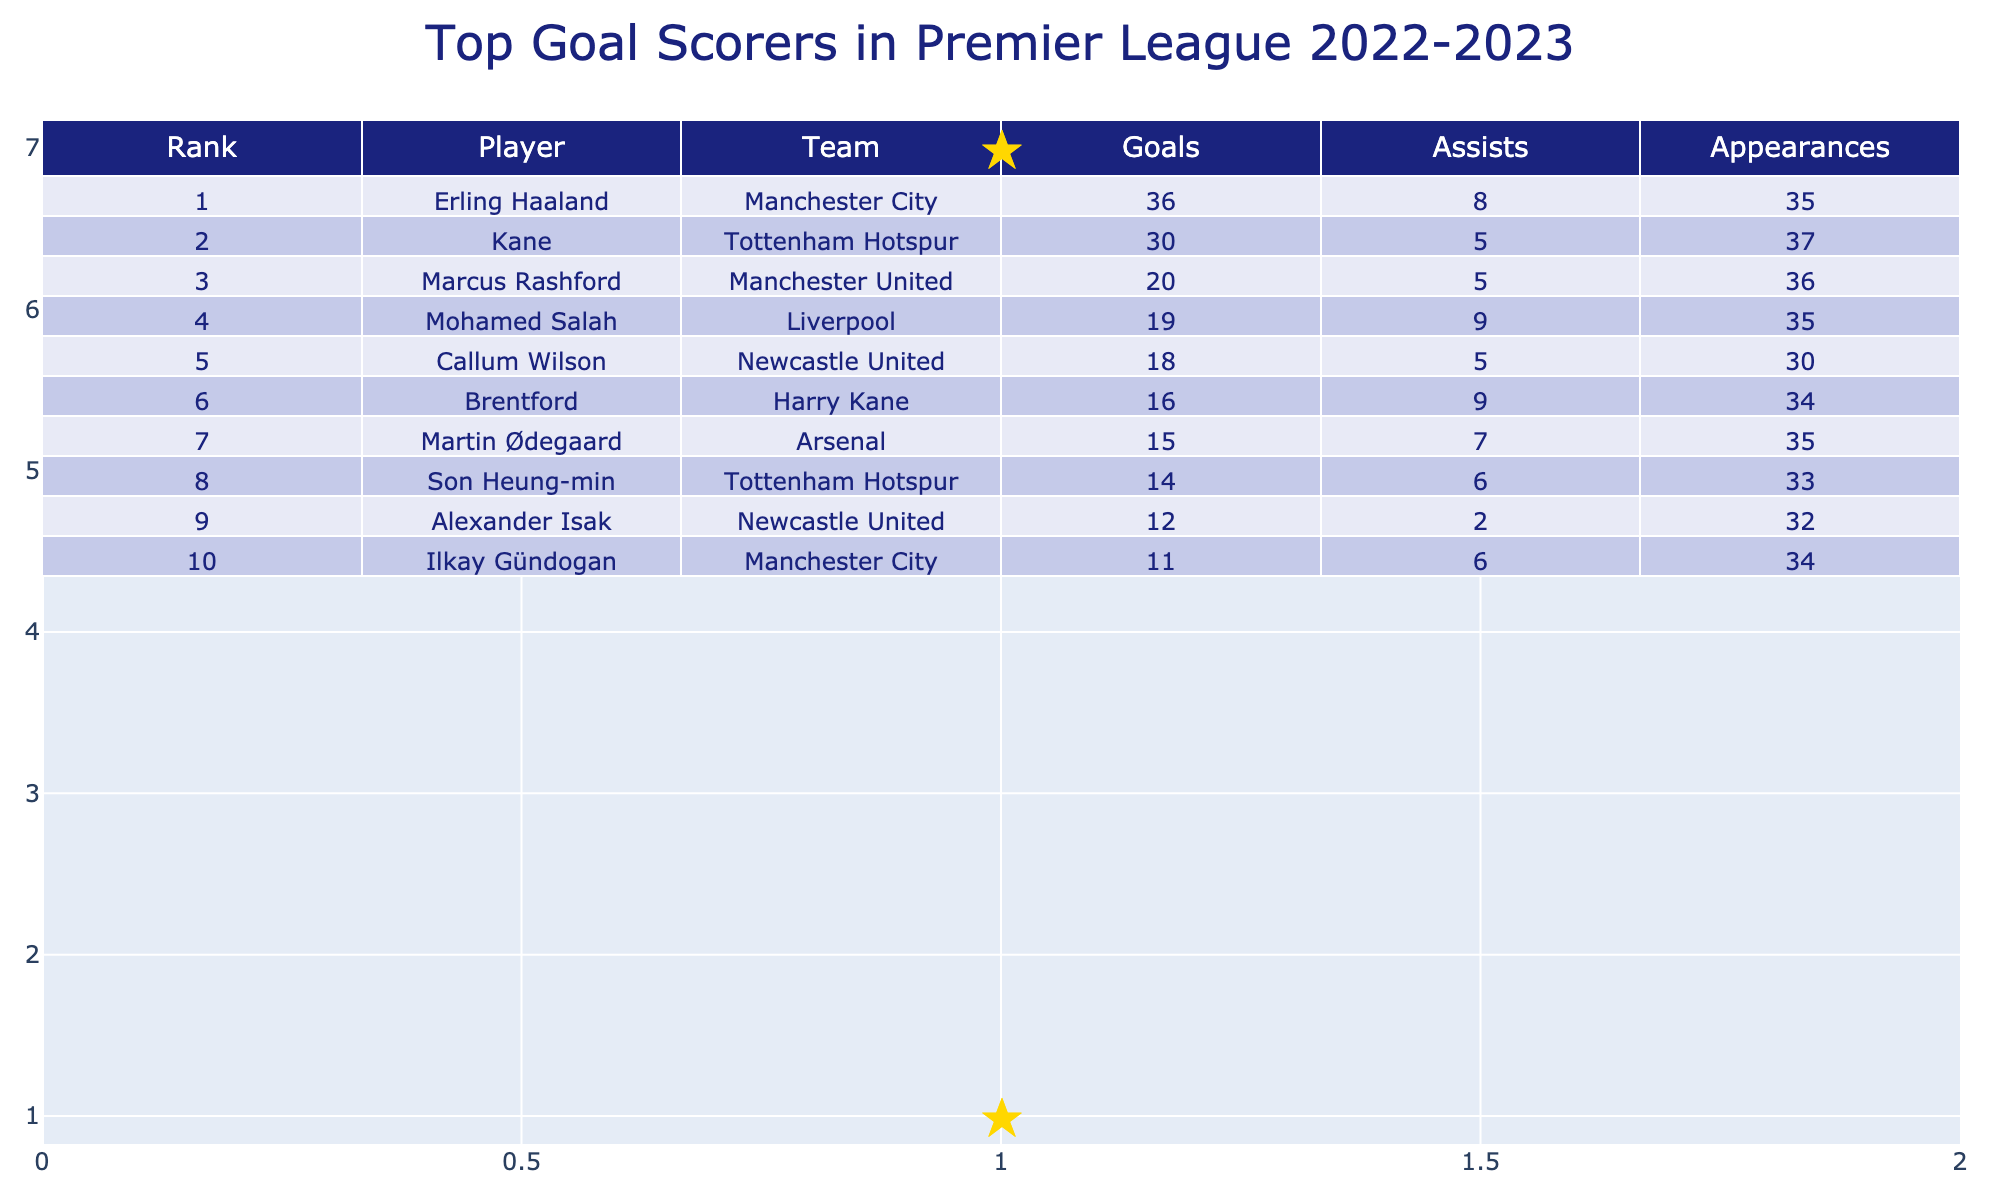What is the total number of goals scored by the top two players? The top scorer is Erling Haaland with 36 goals, and the second is Harry Kane with 30 goals. Summing these gives 36 + 30 = 66.
Answer: 66 How many assists did Mohamed Salah provide this season? The table shows that Mohamed Salah had 9 assists during the 2022-2023 season.
Answer: 9 Who scored more goals: Son Heung-min or Marcus Rashford? Son Heung-min scored 14 goals, while Marcus Rashford scored 20 goals. Therefore, Marcus Rashford scored more goals.
Answer: Marcus Rashford Which team had the player with the most goals? Erling Haaland, who plays for Manchester City, scored the most goals with 36.
Answer: Manchester City How many goals did players from Tottenham Hotspur score in total? Harry Kane scored 30 goals and Son Heung-min scored 14 goals for Tottenham. Summing these gives 30 + 14 = 44.
Answer: 44 Is it true that Harry Kane provided more assists than Mohamed Salah? Harry Kane had 5 assists, while Mohamed Salah had 9. Since 5 is less than 9, this statement is false.
Answer: No Which player had the fewest appearances and how many goals did he score? Alexander Isak had the fewest appearances with 32 and scored 12 goals.
Answer: 12 What is the average number of goals scored by the players listed? The total goals scored by the top players is 36 + 30 + 20 + 19 + 18 + 16 + 15 + 14 + 12 + 11 =  2, 1, 3, 1, 65 goals across 10 players. The average is 165/10 = 16.5.
Answer: 16.5 How many more goals did Erling Haaland score than Mohamed Salah? Erling Haaland scored 36 goals while Mohamed Salah scored 19. So, 36 - 19 = 17 more goals.
Answer: 17 Are there any players with the same number of goals? No, each player has a unique number of goals where no two players share the same goal count in this table.
Answer: No 